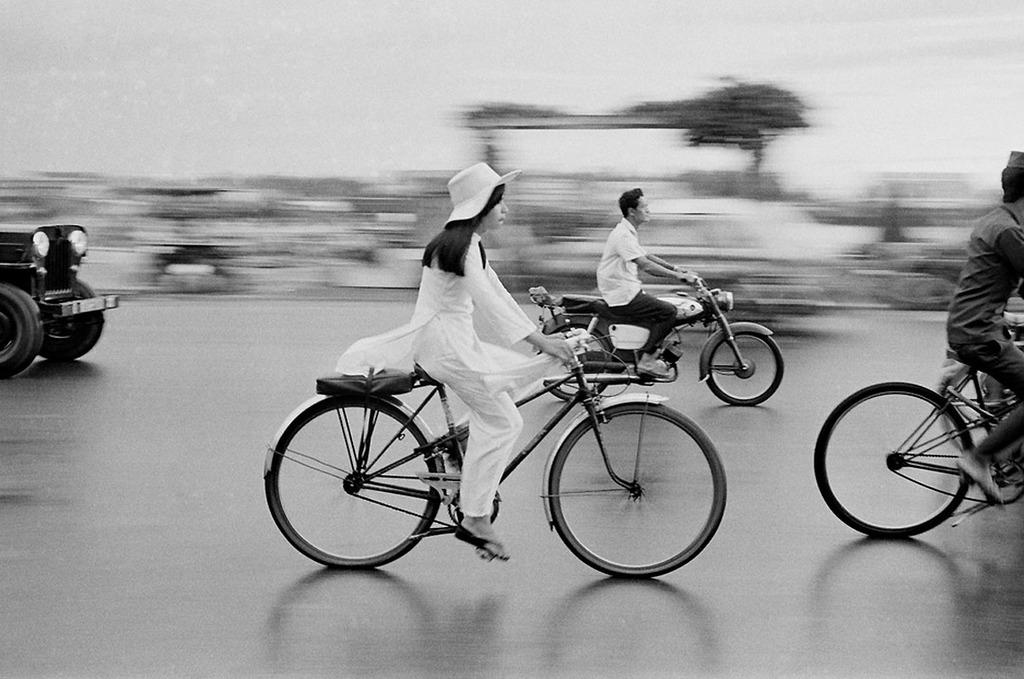What is the color scheme of the image? The image is black and white. How would you describe the background of the image? The background is blurry. What are the persons in the image doing? The persons in the image are riding bicycles on the road. Can you see any vehicles in the image? A partial part of a vehicle is visible in the image. How many noses can be seen on the persons riding bicycles in the image? There is no way to determine the number of noses from the image, as faces are not clearly visible due to the blurry background. 